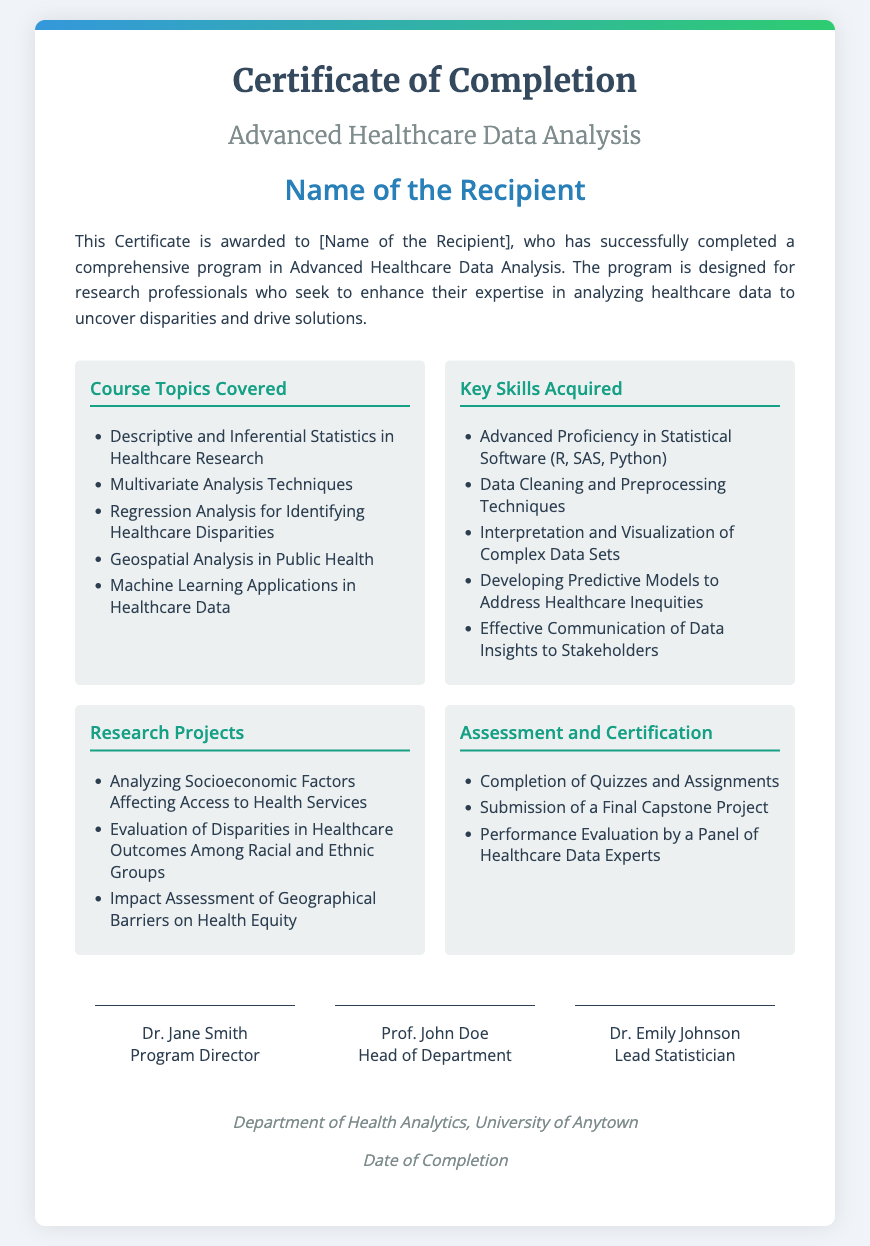What is the title of the certificate? The title of the certificate is explicitly stated at the top of the document.
Answer: Certificate of Completion Who is the recipient of the certificate? The certificate mentions "Name of the Recipient" as a placeholder for the actual recipient's name.
Answer: Name of the Recipient What is one of the course topics covered? The document lists various topics under "Course Topics Covered."
Answer: Descriptive and Inferential Statistics in Healthcare Research What is one key skill acquired during the program? The certificate details skills acquired in a section labeled "Key Skills Acquired."
Answer: Advanced Proficiency in Statistical Software (R, SAS, Python) How many research projects are listed in the document? The document provides information in a section titled "Research Projects," where there are three distinct projects enumerated.
Answer: 3 What is required for assessment and certification? The document outlines the requirements under the section "Assessment and Certification," detailing specific criteria.
Answer: Completion of Quizzes and Assignments Who is the Program Director? The signatories section at the bottom lists the names and titles of officials, including the Program Director.
Answer: Dr. Jane Smith When was this certificate completed? The footer section of the document states a line for completion date, but it does not specify a date.
Answer: Date of Completion What institution awarded this certificate? The footer section indicates the department that issued the certificate.
Answer: Department of Health Analytics, University of Anytown 